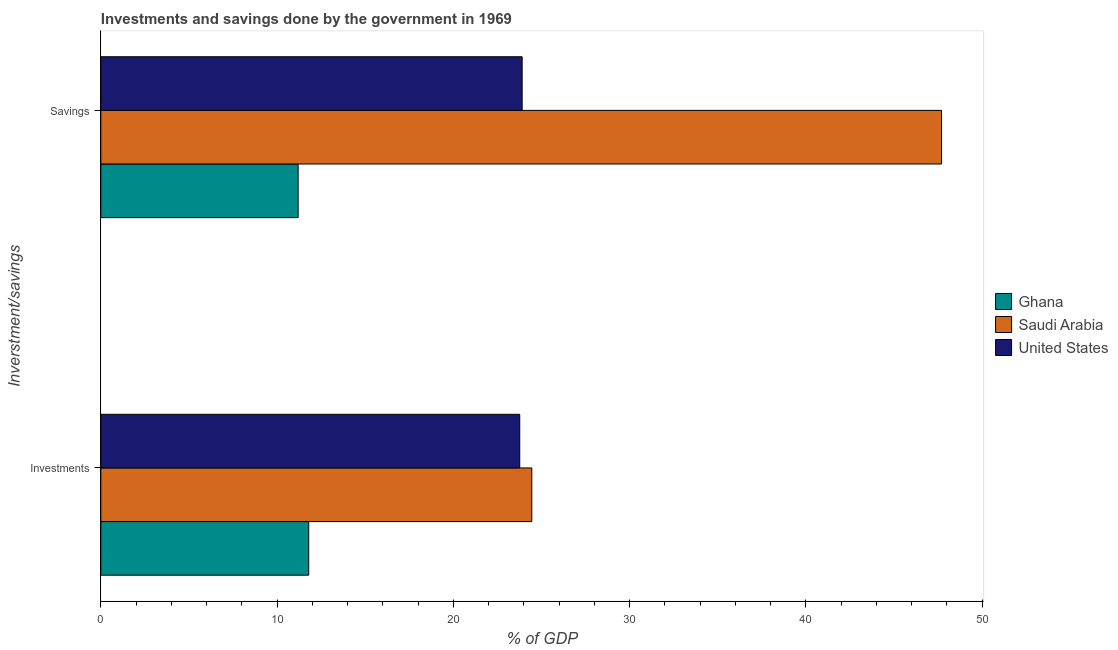How many groups of bars are there?
Offer a terse response. 2. How many bars are there on the 1st tick from the bottom?
Offer a very short reply. 3. What is the label of the 2nd group of bars from the top?
Give a very brief answer. Investments. What is the investments of government in United States?
Your response must be concise. 23.77. Across all countries, what is the maximum savings of government?
Ensure brevity in your answer.  47.7. Across all countries, what is the minimum savings of government?
Your response must be concise. 11.19. In which country was the savings of government maximum?
Your answer should be compact. Saudi Arabia. In which country was the investments of government minimum?
Your response must be concise. Ghana. What is the total investments of government in the graph?
Give a very brief answer. 60.01. What is the difference between the savings of government in United States and that in Ghana?
Your response must be concise. 12.71. What is the difference between the savings of government in Ghana and the investments of government in Saudi Arabia?
Give a very brief answer. -13.26. What is the average savings of government per country?
Make the answer very short. 27.6. What is the difference between the savings of government and investments of government in Ghana?
Your answer should be compact. -0.6. In how many countries, is the investments of government greater than 14 %?
Give a very brief answer. 2. What is the ratio of the investments of government in United States to that in Saudi Arabia?
Your answer should be compact. 0.97. Is the investments of government in Ghana less than that in Saudi Arabia?
Offer a terse response. Yes. In how many countries, is the investments of government greater than the average investments of government taken over all countries?
Offer a terse response. 2. What does the 3rd bar from the bottom in Savings represents?
Ensure brevity in your answer.  United States. How many bars are there?
Provide a short and direct response. 6. How many countries are there in the graph?
Make the answer very short. 3. Does the graph contain grids?
Your response must be concise. No. How are the legend labels stacked?
Keep it short and to the point. Vertical. What is the title of the graph?
Offer a terse response. Investments and savings done by the government in 1969. What is the label or title of the X-axis?
Your answer should be compact. % of GDP. What is the label or title of the Y-axis?
Ensure brevity in your answer.  Inverstment/savings. What is the % of GDP in Ghana in Investments?
Your answer should be very brief. 11.79. What is the % of GDP of Saudi Arabia in Investments?
Your answer should be very brief. 24.45. What is the % of GDP in United States in Investments?
Your answer should be compact. 23.77. What is the % of GDP of Ghana in Savings?
Give a very brief answer. 11.19. What is the % of GDP in Saudi Arabia in Savings?
Ensure brevity in your answer.  47.7. What is the % of GDP in United States in Savings?
Offer a very short reply. 23.9. Across all Inverstment/savings, what is the maximum % of GDP of Ghana?
Your answer should be very brief. 11.79. Across all Inverstment/savings, what is the maximum % of GDP of Saudi Arabia?
Offer a terse response. 47.7. Across all Inverstment/savings, what is the maximum % of GDP in United States?
Your answer should be very brief. 23.9. Across all Inverstment/savings, what is the minimum % of GDP in Ghana?
Give a very brief answer. 11.19. Across all Inverstment/savings, what is the minimum % of GDP of Saudi Arabia?
Offer a very short reply. 24.45. Across all Inverstment/savings, what is the minimum % of GDP in United States?
Keep it short and to the point. 23.77. What is the total % of GDP of Ghana in the graph?
Keep it short and to the point. 22.99. What is the total % of GDP of Saudi Arabia in the graph?
Keep it short and to the point. 72.15. What is the total % of GDP in United States in the graph?
Provide a short and direct response. 47.67. What is the difference between the % of GDP of Ghana in Investments and that in Savings?
Ensure brevity in your answer.  0.6. What is the difference between the % of GDP of Saudi Arabia in Investments and that in Savings?
Your answer should be very brief. -23.25. What is the difference between the % of GDP of United States in Investments and that in Savings?
Keep it short and to the point. -0.14. What is the difference between the % of GDP of Ghana in Investments and the % of GDP of Saudi Arabia in Savings?
Provide a succinct answer. -35.9. What is the difference between the % of GDP of Ghana in Investments and the % of GDP of United States in Savings?
Ensure brevity in your answer.  -12.11. What is the difference between the % of GDP of Saudi Arabia in Investments and the % of GDP of United States in Savings?
Give a very brief answer. 0.55. What is the average % of GDP of Ghana per Inverstment/savings?
Ensure brevity in your answer.  11.49. What is the average % of GDP of Saudi Arabia per Inverstment/savings?
Provide a short and direct response. 36.07. What is the average % of GDP in United States per Inverstment/savings?
Make the answer very short. 23.84. What is the difference between the % of GDP in Ghana and % of GDP in Saudi Arabia in Investments?
Ensure brevity in your answer.  -12.66. What is the difference between the % of GDP in Ghana and % of GDP in United States in Investments?
Offer a very short reply. -11.97. What is the difference between the % of GDP in Saudi Arabia and % of GDP in United States in Investments?
Offer a very short reply. 0.68. What is the difference between the % of GDP in Ghana and % of GDP in Saudi Arabia in Savings?
Offer a terse response. -36.5. What is the difference between the % of GDP in Ghana and % of GDP in United States in Savings?
Make the answer very short. -12.71. What is the difference between the % of GDP in Saudi Arabia and % of GDP in United States in Savings?
Offer a very short reply. 23.79. What is the ratio of the % of GDP of Ghana in Investments to that in Savings?
Your answer should be compact. 1.05. What is the ratio of the % of GDP of Saudi Arabia in Investments to that in Savings?
Your answer should be very brief. 0.51. What is the ratio of the % of GDP of United States in Investments to that in Savings?
Your response must be concise. 0.99. What is the difference between the highest and the second highest % of GDP in Ghana?
Keep it short and to the point. 0.6. What is the difference between the highest and the second highest % of GDP in Saudi Arabia?
Your answer should be compact. 23.25. What is the difference between the highest and the second highest % of GDP in United States?
Offer a terse response. 0.14. What is the difference between the highest and the lowest % of GDP in Ghana?
Offer a terse response. 0.6. What is the difference between the highest and the lowest % of GDP in Saudi Arabia?
Provide a short and direct response. 23.25. What is the difference between the highest and the lowest % of GDP of United States?
Ensure brevity in your answer.  0.14. 